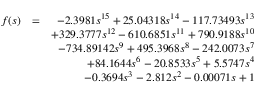<formula> <loc_0><loc_0><loc_500><loc_500>\begin{array} { r l r } { f ( s ) } & { = } & { - 2 . 3 9 8 1 s ^ { 1 5 } + 2 5 . 0 4 3 1 8 s ^ { 1 4 } - 1 1 7 . 7 3 4 9 3 s ^ { 1 3 } } \\ & { + 3 2 9 . 3 7 7 7 s ^ { 1 2 } - 6 1 0 . 6 8 5 1 s ^ { 1 1 } + 7 9 0 . 9 1 8 8 s ^ { 1 0 } } \\ & { - 7 3 4 . 8 9 1 4 2 s ^ { 9 } + 4 9 5 . 3 9 6 8 s ^ { 8 } - 2 4 2 . 0 0 7 3 s ^ { 7 } } \\ & { + 8 4 . 1 6 4 4 s ^ { 6 } - 2 0 . 8 5 3 3 s ^ { 5 } + 5 . 5 7 4 7 s ^ { 4 } } \\ & { - 0 . 3 6 9 4 s ^ { 3 } - 2 . 8 1 2 s ^ { 2 } - 0 . 0 0 0 7 1 s + 1 } \end{array}</formula> 